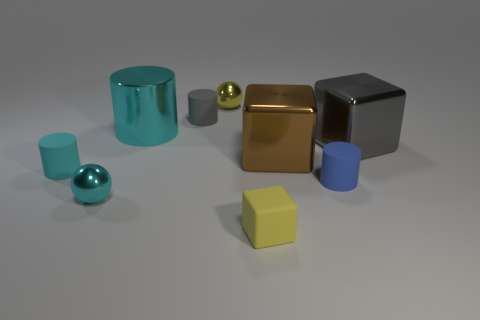Subtract all cyan cylinders. How many were subtracted if there are1cyan cylinders left? 1 Add 1 cyan shiny cylinders. How many objects exist? 10 Subtract all cylinders. How many objects are left? 5 Add 5 tiny metal spheres. How many tiny metal spheres are left? 7 Add 1 small red matte cubes. How many small red matte cubes exist? 1 Subtract 0 red spheres. How many objects are left? 9 Subtract all cyan shiny cylinders. Subtract all tiny cylinders. How many objects are left? 5 